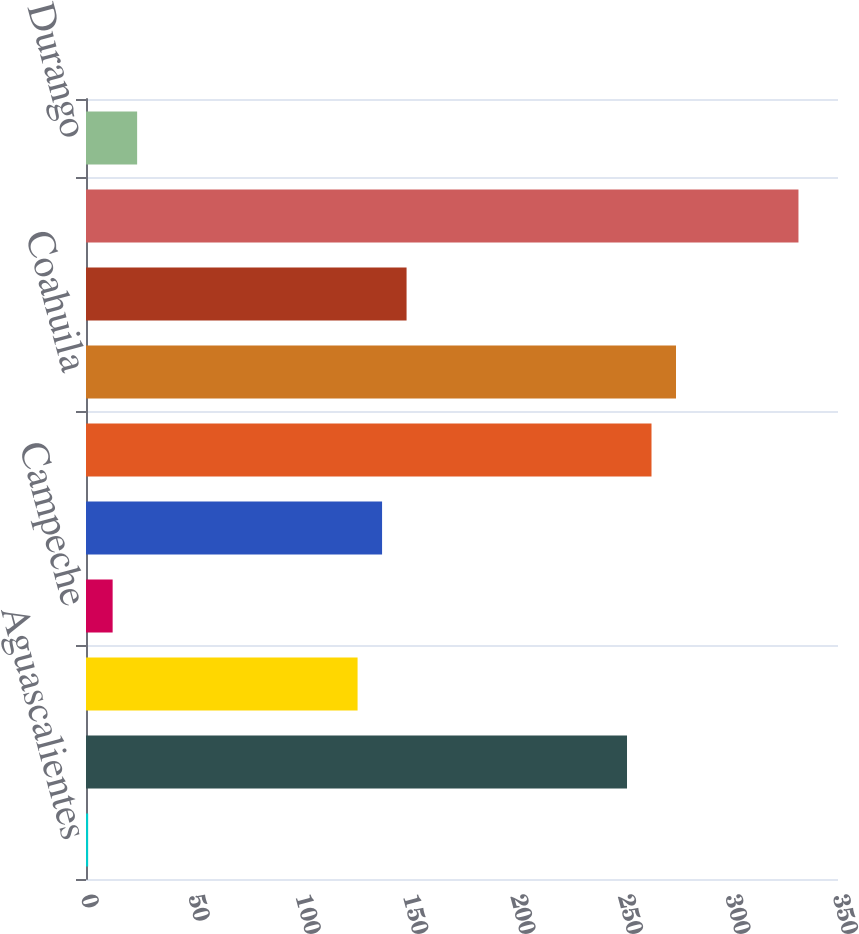Convert chart to OTSL. <chart><loc_0><loc_0><loc_500><loc_500><bar_chart><fcel>Aguascalientes<fcel>Baja California Norte<fcel>Baja California Sur<fcel>Campeche<fcel>Chiapas<fcel>Chihuahua<fcel>Coahuila<fcel>Colima<fcel>Distrito Federal<fcel>Durango<nl><fcel>1<fcel>251.8<fcel>126.4<fcel>12.4<fcel>137.8<fcel>263.2<fcel>274.6<fcel>149.2<fcel>331.6<fcel>23.8<nl></chart> 